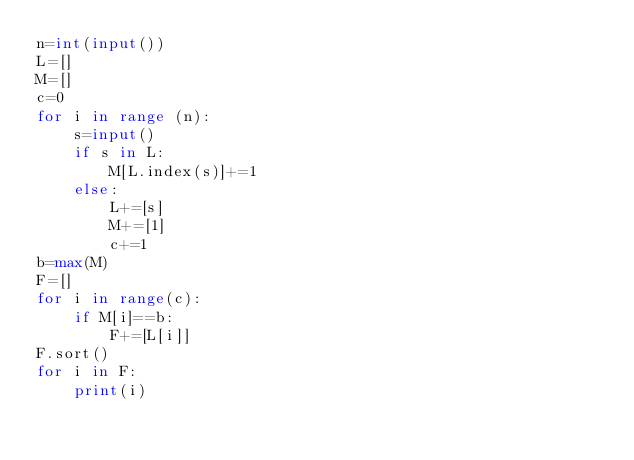<code> <loc_0><loc_0><loc_500><loc_500><_Python_>n=int(input())
L=[]
M=[]
c=0
for i in range (n):
    s=input()
    if s in L:
        M[L.index(s)]+=1
    else:
        L+=[s]
        M+=[1]
        c+=1
b=max(M)
F=[]
for i in range(c):
    if M[i]==b:
        F+=[L[i]]
F.sort()
for i in F:
    print(i)
    
</code> 